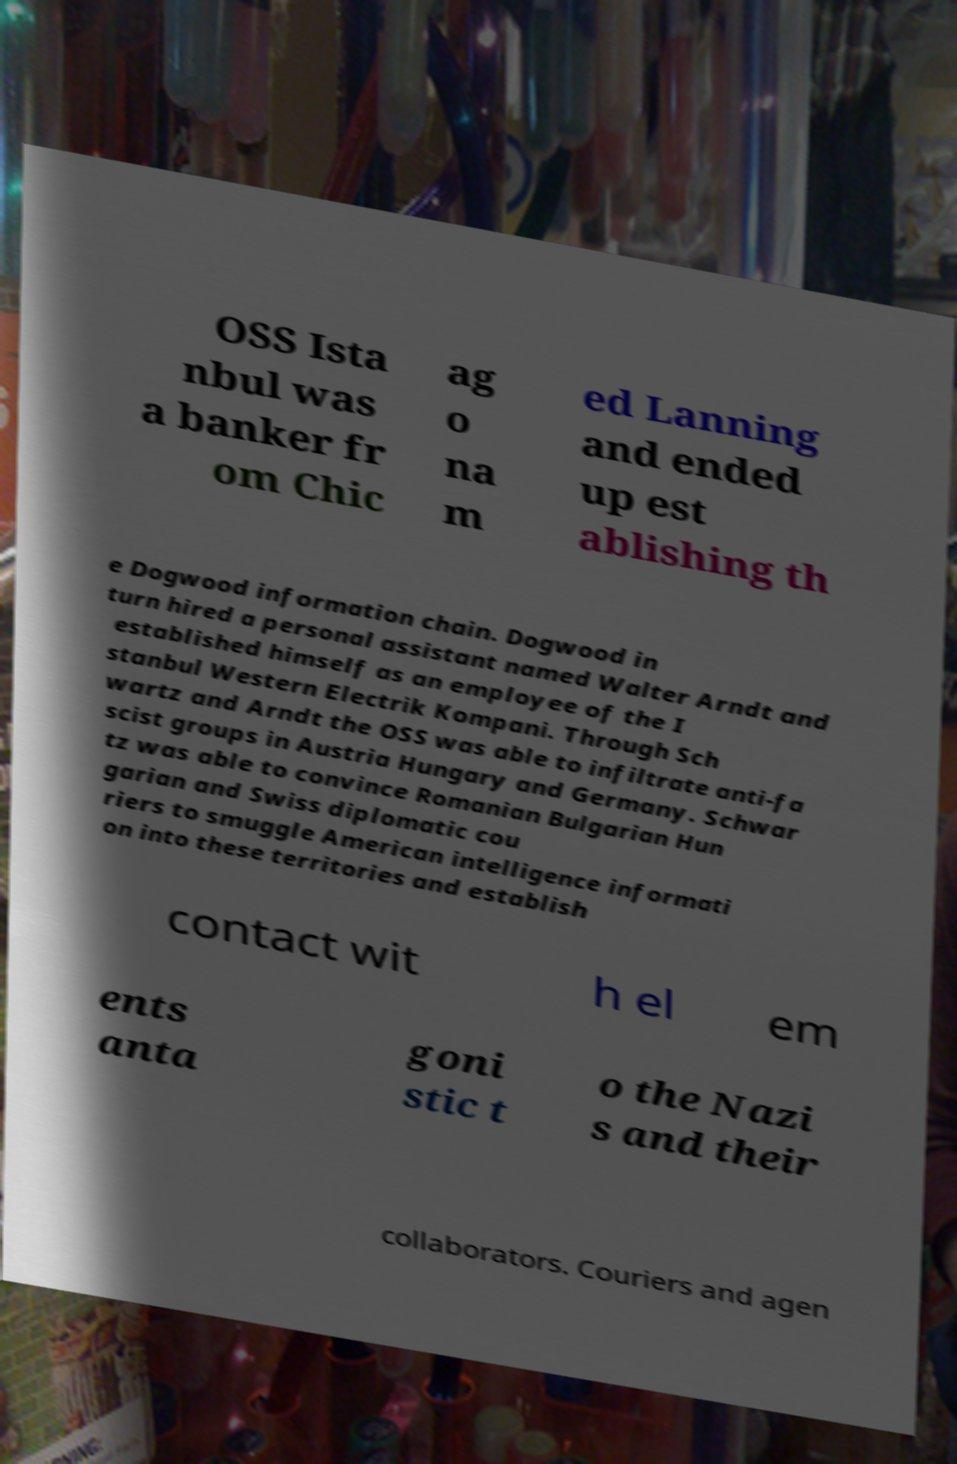There's text embedded in this image that I need extracted. Can you transcribe it verbatim? OSS Ista nbul was a banker fr om Chic ag o na m ed Lanning and ended up est ablishing th e Dogwood information chain. Dogwood in turn hired a personal assistant named Walter Arndt and established himself as an employee of the I stanbul Western Electrik Kompani. Through Sch wartz and Arndt the OSS was able to infiltrate anti-fa scist groups in Austria Hungary and Germany. Schwar tz was able to convince Romanian Bulgarian Hun garian and Swiss diplomatic cou riers to smuggle American intelligence informati on into these territories and establish contact wit h el em ents anta goni stic t o the Nazi s and their collaborators. Couriers and agen 